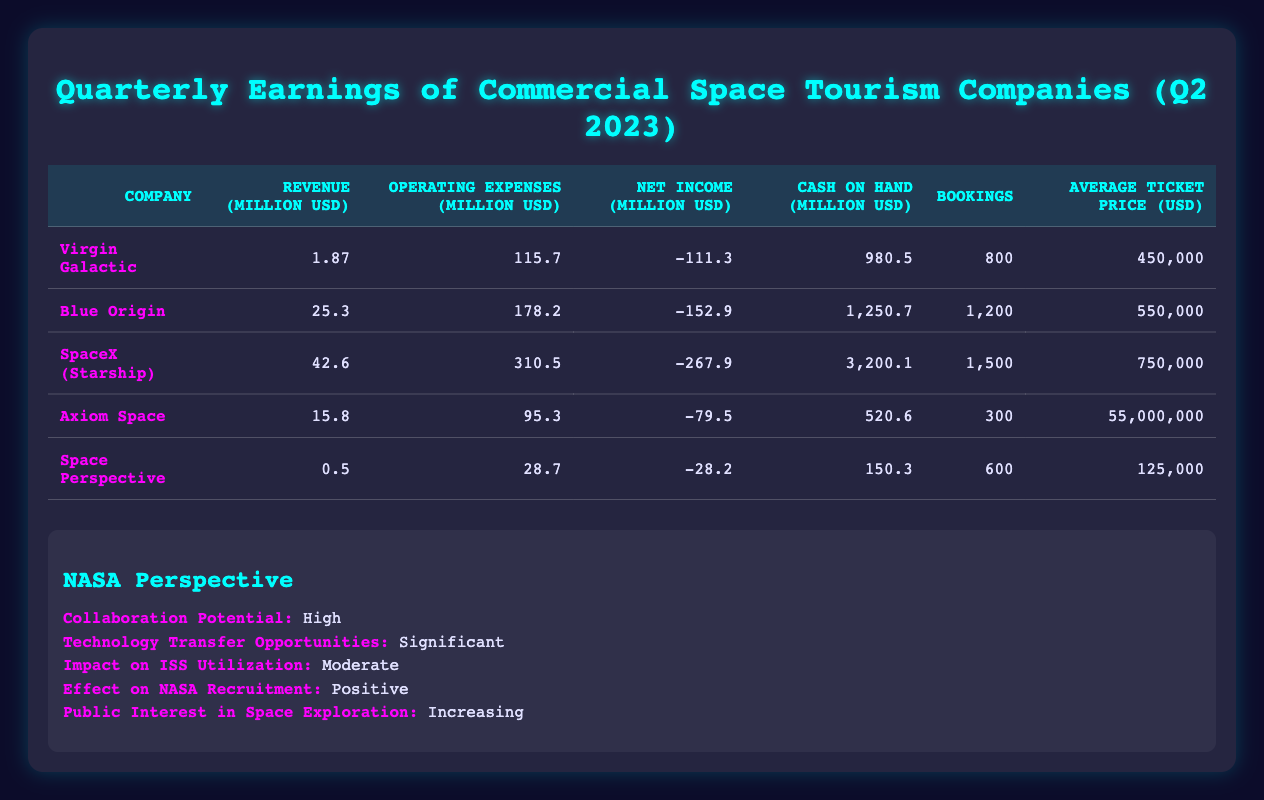What is the net income for Virgin Galactic? The net income for Virgin Galactic is shown directly in the table under the Net Income column for that company, which is -111.3 million USD.
Answer: -111.3 million USD Which company has the highest cash on hand? By comparing the Cash on Hand values across all companies in the table, SpaceX (Starship) has the highest value at 3200.1 million USD.
Answer: SpaceX (Starship) What is the average ticket price of all companies combined? To find the average ticket price, sum all average ticket prices: (450000 + 550000 + 750000 + 55000000 + 125000) = 56800000. Divide this sum by the number of companies (5): 56800000/5 = 11360000.
Answer: 11360000 Did Axiom Space generate a profit in Q2 2023? Axiom Space's net income is listed as -79.5 million USD, which indicates that it did not generate a profit.
Answer: No Which company has the lowest revenue? Looking at the Revenue column in the table, Space Perspective has the lowest revenue at 0.5 million USD compared to the other companies.
Answer: Space Perspective What is the total operating expense for all companies combined? The total operating expenses are calculated by adding the operating expenses of each company: (115.7 + 178.2 + 310.5 + 95.3 + 28.7) = 728.4 million USD.
Answer: 728.4 million USD Is the average ticket price of Blue Origin higher than that of Virgin Galactic? Comparing the average ticket prices, Blue Origin's average ticket price is 550,000 USD and Virgin Galactic's is 450,000 USD. Since 550,000 is greater than 450,000, the answer is yes.
Answer: Yes What percentage of total bookings were made with SpaceX (Starship)? First, total bookings are found: (800 + 1200 + 1500 + 300 + 600) = 3400. SpaceX (Starship) has 1500 bookings. The percentage is (1500/3400) * 100 = 44.12%.
Answer: 44.12% 